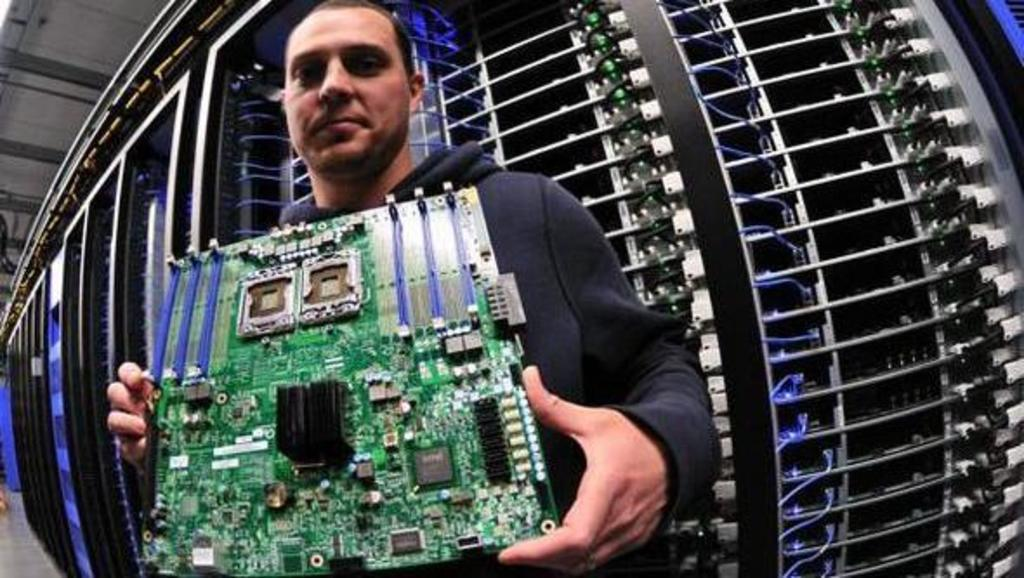What is the main subject of the image? There is a person in the image. What is the person holding in the image? The person is holding a chipboard. What can be seen in the background of the image? There is a data-center in the background of the image. What type of coat is the person wearing in the image? There is no coat visible in the image; the person is holding a chipboard. Is there a crib present in the image? No, there is no crib present in the image. 